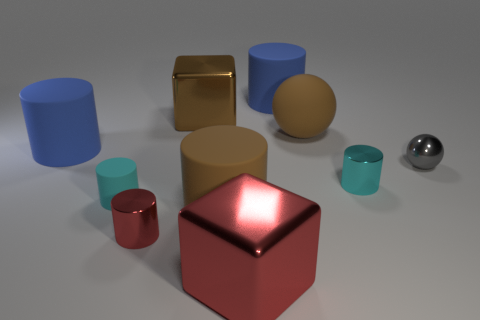Subtract 1 balls. How many balls are left? 1 Subtract all metallic cylinders. How many cylinders are left? 4 Subtract all cylinders. How many objects are left? 4 Subtract all blue cylinders. How many cylinders are left? 4 Subtract 0 yellow cubes. How many objects are left? 10 Subtract all brown cylinders. Subtract all cyan spheres. How many cylinders are left? 5 Subtract all purple blocks. How many brown balls are left? 1 Subtract all brown metal cubes. Subtract all tiny red shiny objects. How many objects are left? 8 Add 2 brown shiny objects. How many brown shiny objects are left? 3 Add 4 small gray shiny balls. How many small gray shiny balls exist? 5 